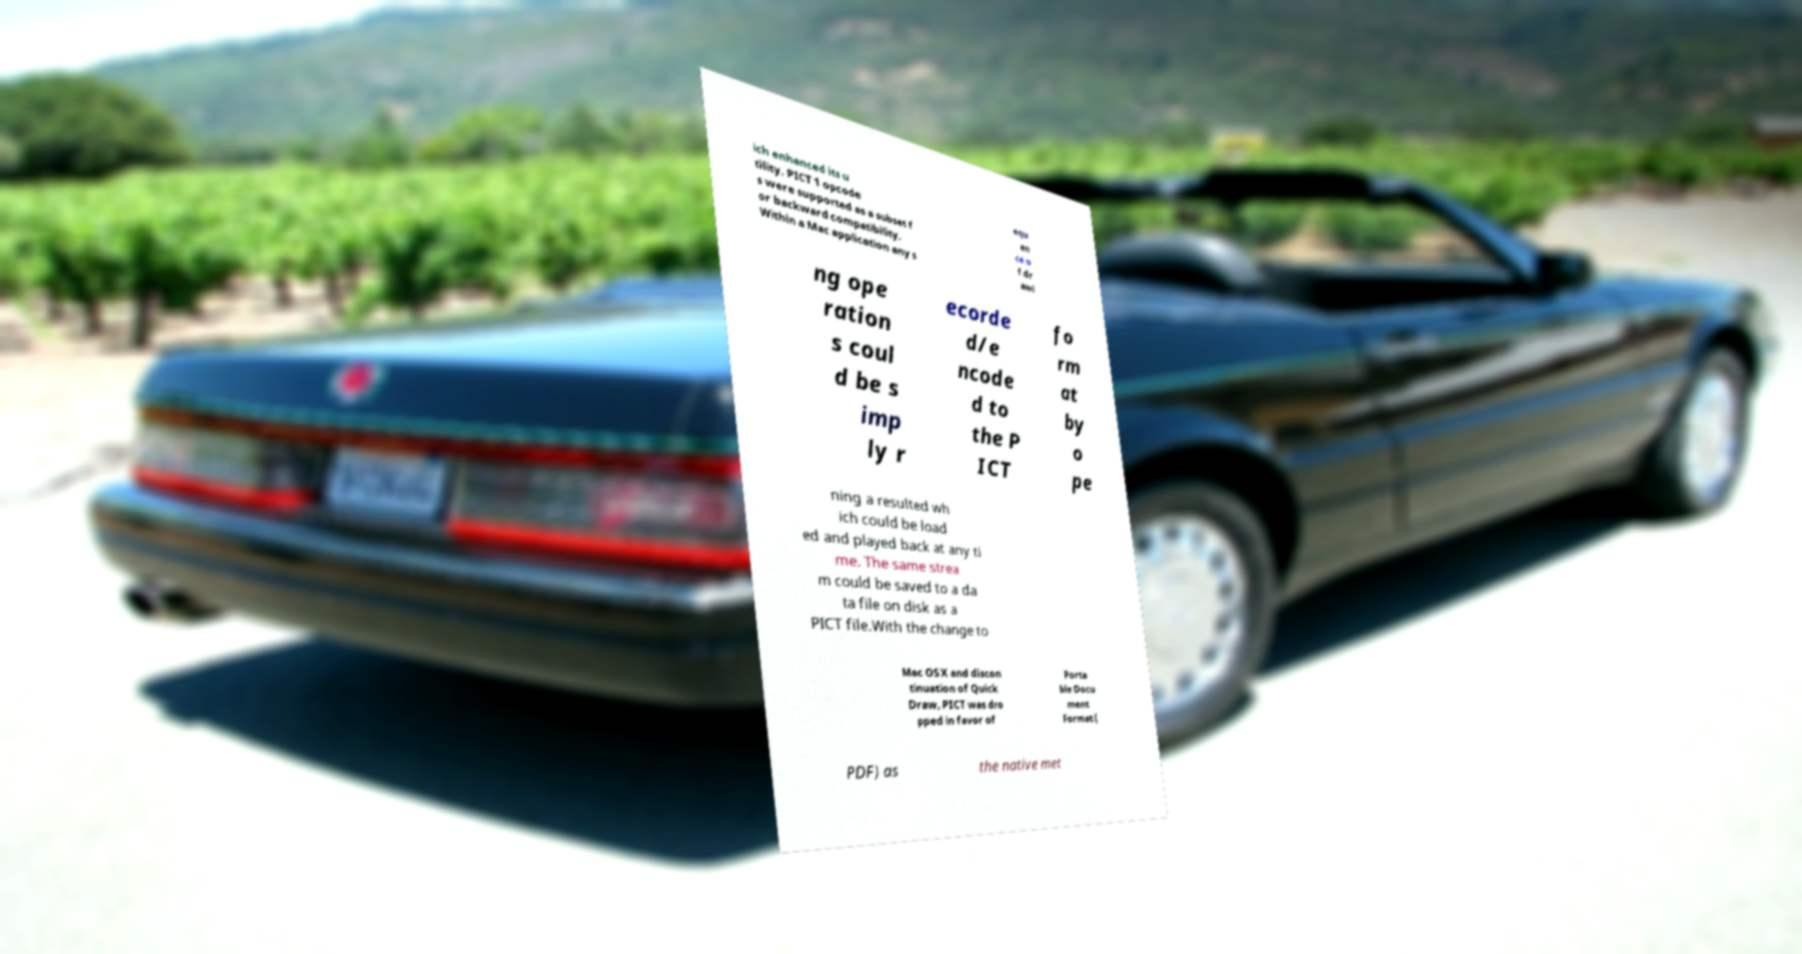For documentation purposes, I need the text within this image transcribed. Could you provide that? ich enhanced its u tility. PICT 1 opcode s were supported as a subset f or backward compatibility. Within a Mac application any s equ en ce o f dr awi ng ope ration s coul d be s imp ly r ecorde d/e ncode d to the P ICT fo rm at by o pe ning a resulted wh ich could be load ed and played back at any ti me. The same strea m could be saved to a da ta file on disk as a PICT file.With the change to Mac OS X and discon tinuation of Quick Draw, PICT was dro pped in favor of Porta ble Docu ment Format ( PDF) as the native met 